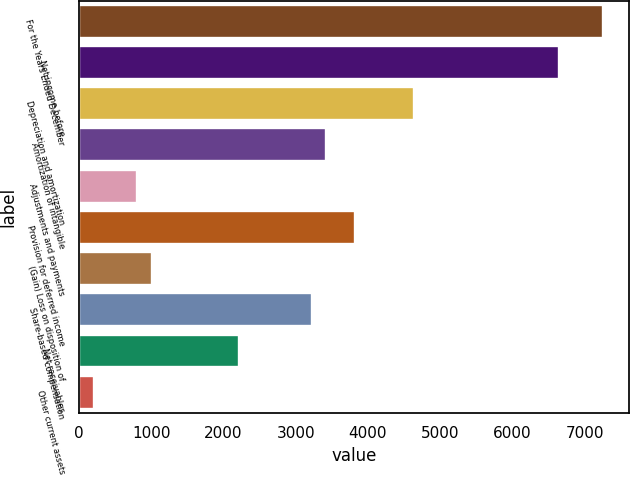<chart> <loc_0><loc_0><loc_500><loc_500><bar_chart><fcel>For the Years Ended December<fcel>Net income before<fcel>Depreciation and amortization<fcel>Amortization of intangible<fcel>Adjustments and payments<fcel>Provision for deferred income<fcel>(Gain) Loss on disposition of<fcel>Share-based compensation<fcel>Net receivables<fcel>Other current assets<nl><fcel>7248.8<fcel>6644.9<fcel>4631.9<fcel>3424.1<fcel>807.2<fcel>3826.7<fcel>1008.5<fcel>3222.8<fcel>2216.3<fcel>203.3<nl></chart> 